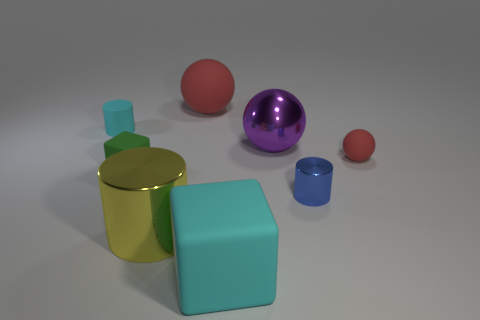What number of cyan rubber objects have the same shape as the tiny green rubber thing?
Your answer should be very brief. 1. There is a green object that is made of the same material as the large cube; what size is it?
Your answer should be compact. Small. Is the size of the blue metal thing the same as the cyan matte cube?
Keep it short and to the point. No. Are there any large red matte spheres?
Provide a succinct answer. Yes. There is a block that is the same color as the small rubber cylinder; what is its size?
Make the answer very short. Large. How big is the cyan object that is behind the cube right of the rubber block that is behind the yellow cylinder?
Make the answer very short. Small. What number of tiny spheres have the same material as the cyan block?
Offer a very short reply. 1. How many yellow metal objects are the same size as the green object?
Keep it short and to the point. 0. What is the material of the cyan thing left of the big rubber thing behind the metallic object on the left side of the big purple object?
Offer a very short reply. Rubber. How many things are large cyan rubber things or purple objects?
Your answer should be compact. 2. 